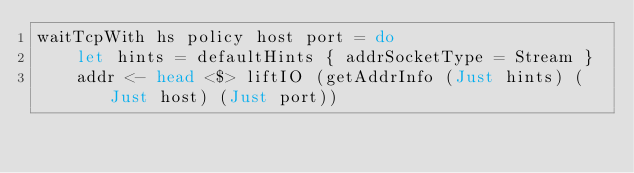Convert code to text. <code><loc_0><loc_0><loc_500><loc_500><_Haskell_>waitTcpWith hs policy host port = do
    let hints = defaultHints { addrSocketType = Stream }
    addr <- head <$> liftIO (getAddrInfo (Just hints) (Just host) (Just port))</code> 